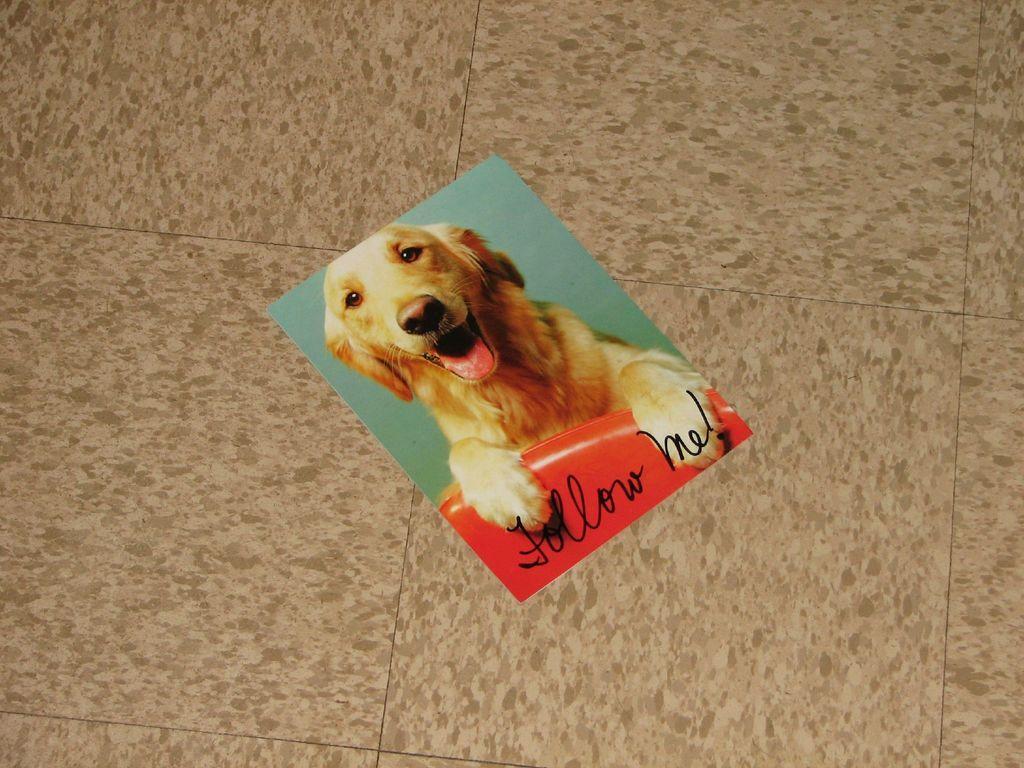Can you describe this image briefly? In this image we can see a photograph of a dog present on the floor. 